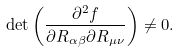<formula> <loc_0><loc_0><loc_500><loc_500>\det \left ( \frac { \partial ^ { 2 } f } { \partial R _ { \alpha \beta } \partial R _ { \mu \nu } } \right ) \neq 0 .</formula> 